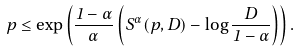Convert formula to latex. <formula><loc_0><loc_0><loc_500><loc_500>p \leq \exp \left ( \frac { 1 - \alpha } { \alpha } \left ( S ^ { \alpha } ( p , D ) - \log \frac { D } { 1 - \alpha } \right ) \right ) .</formula> 